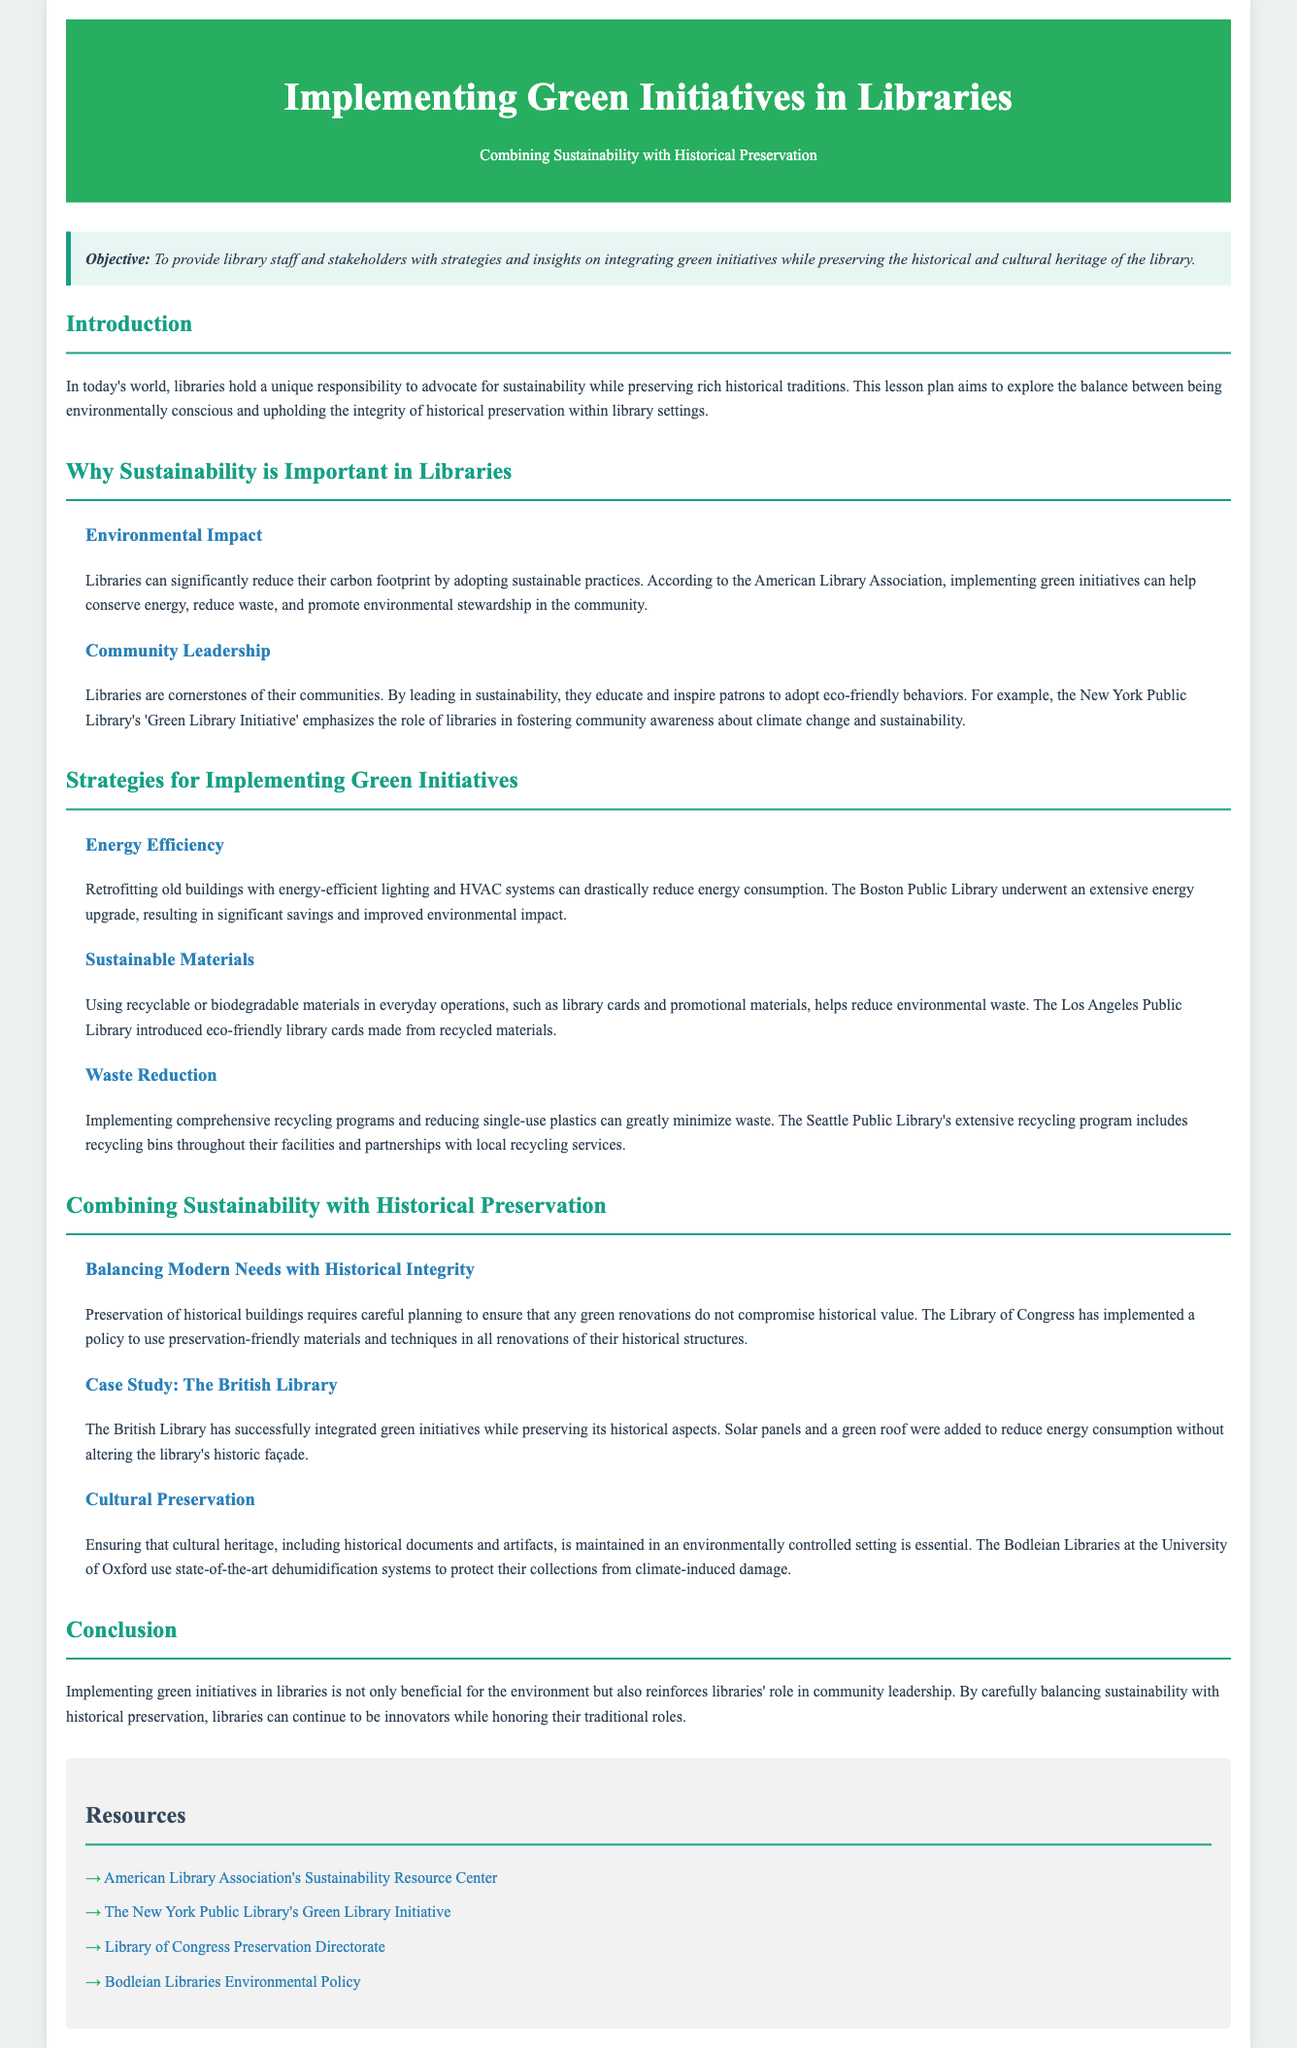what is the main objective of the lesson plan? The objective is to provide library staff and stakeholders with strategies and insights on integrating green initiatives while preserving historical and cultural heritage.
Answer: To provide library staff and stakeholders with strategies and insights on integrating green initiatives while preserving historical and cultural heritage which library implemented a 'Green Library Initiative'? The New York Public Library emphasized the role of libraries in fostering community awareness about climate change and sustainability.
Answer: The New York Public Library what is one strategy for achieving energy efficiency mentioned? Retrofitting old buildings with energy-efficient lighting and HVAC systems can drastically reduce energy consumption.
Answer: Retrofitting old buildings what type of materials does the Los Angeles Public Library use for library cards? The Los Angeles Public Library introduced eco-friendly library cards made from recycled materials.
Answer: Recycled materials what example is given for balancing modern needs with historical integrity? The Library of Congress has implemented a policy to use preservation-friendly materials and techniques in all renovations of their historical structures.
Answer: The Library of Congress which sustainability practice does the Seattle Public Library implement? The Seattle Public Library's extensive recycling program includes recycling bins throughout their facilities and partnerships with local recycling services.
Answer: Recycling program how does the Bodleian Libraries maintain their collections? The Bodleian Libraries at the University of Oxford use state-of-the-art dehumidification systems to protect their collections from climate-induced damage.
Answer: Dehumidification systems what is the concluding thought regarding green initiatives in libraries? Implementing green initiatives in libraries is not only beneficial for the environment but also reinforces libraries' role in community leadership.
Answer: Reinforces libraries' role in community leadership 